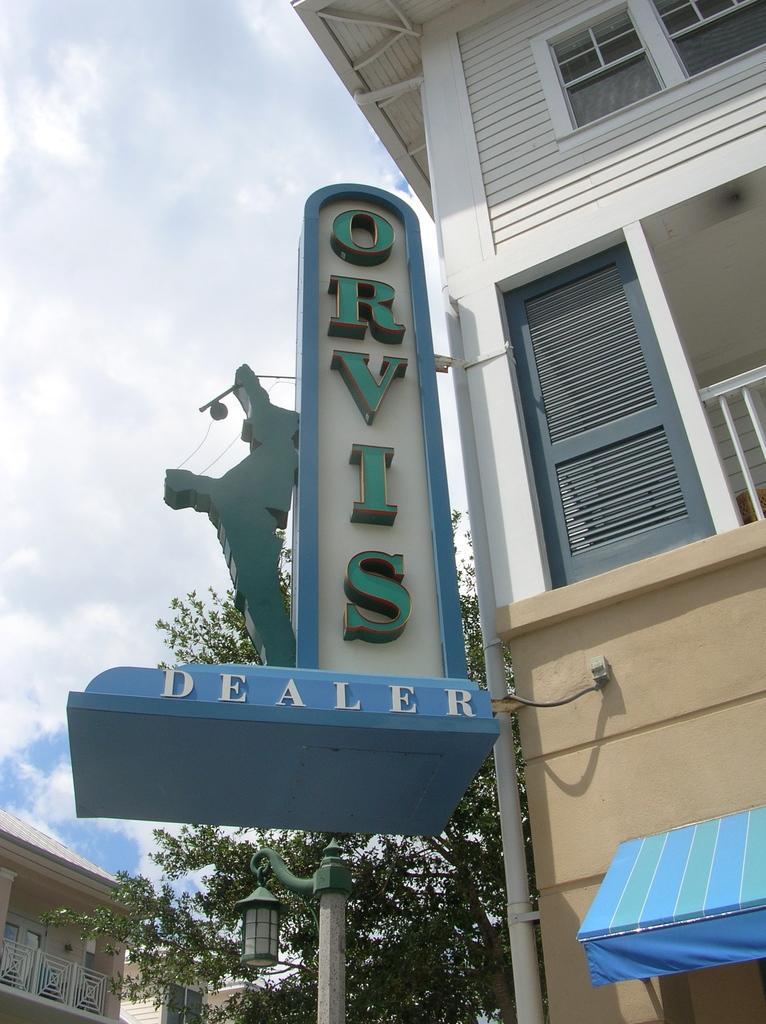Can you describe this image briefly? This picture might be taken from outside of the building and it is sunny. In this image, on the right side, we can see a building, doors, glass windows and metal rods. In the middle of the image, we can see some hoardings, trees, street lights. On the left corner, we can also see another building, doors, glass window. On the top, we can see a sky. 